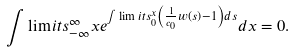<formula> <loc_0><loc_0><loc_500><loc_500>\int \lim i t s _ { - \infty } ^ { \infty } x e ^ { \int \lim i t s _ { 0 } ^ { x } \left ( \frac { 1 } { c _ { 0 } } w \left ( s \right ) - 1 \right ) d s } d x = 0 .</formula> 